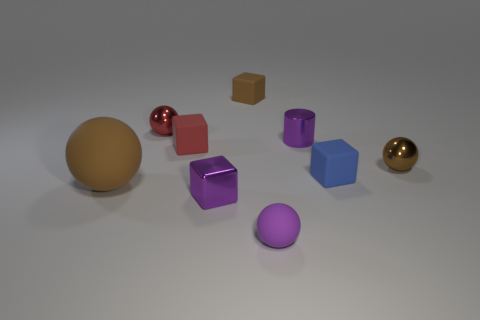There is a small matte object that is the same color as the cylinder; what is its shape?
Make the answer very short. Sphere. The small blue object has what shape?
Offer a very short reply. Cube. Do the tiny cylinder and the purple ball have the same material?
Give a very brief answer. No. Are there an equal number of tiny blue cubes that are to the left of the small purple shiny cube and tiny brown objects in front of the large brown thing?
Give a very brief answer. Yes. There is a tiny purple metal object that is in front of the cube that is on the right side of the tiny brown block; is there a small metal thing left of it?
Provide a succinct answer. Yes. Is the size of the brown metal object the same as the brown matte sphere?
Your answer should be compact. No. What color is the tiny ball on the left side of the small rubber object that is behind the small ball that is behind the brown shiny thing?
Provide a succinct answer. Red. How many large matte spheres are the same color as the cylinder?
Give a very brief answer. 0. What number of large objects are either blue things or rubber objects?
Provide a succinct answer. 1. Are there any blue rubber things that have the same shape as the red rubber object?
Provide a short and direct response. Yes. 